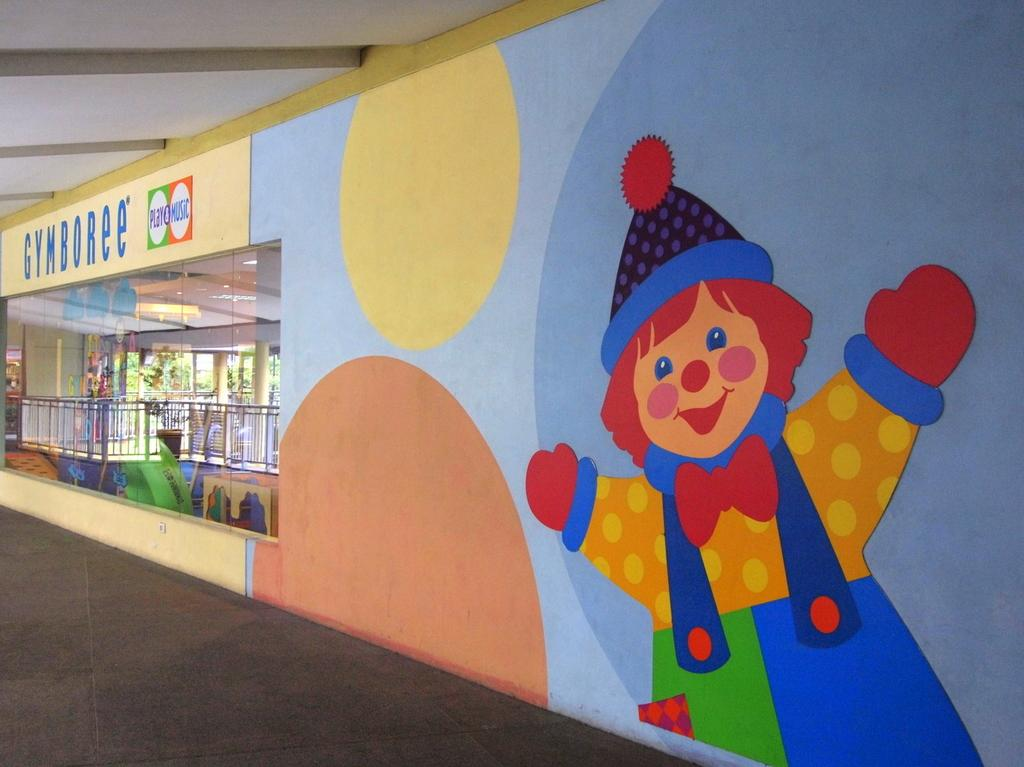What is present on the wall in the image? There are paintings on the wall in the image. What can be observed about the paintings? The paintings are in multiple colors. What other architectural features can be seen in the background of the image? There is a railing and pillars visible in the background. What type of vegetation is present in the background? There are trees in green color in the background. What is the relation between the houses in the image? There are no houses present in the image; it features a wall with paintings, a railing, pillars, and trees in the background. 